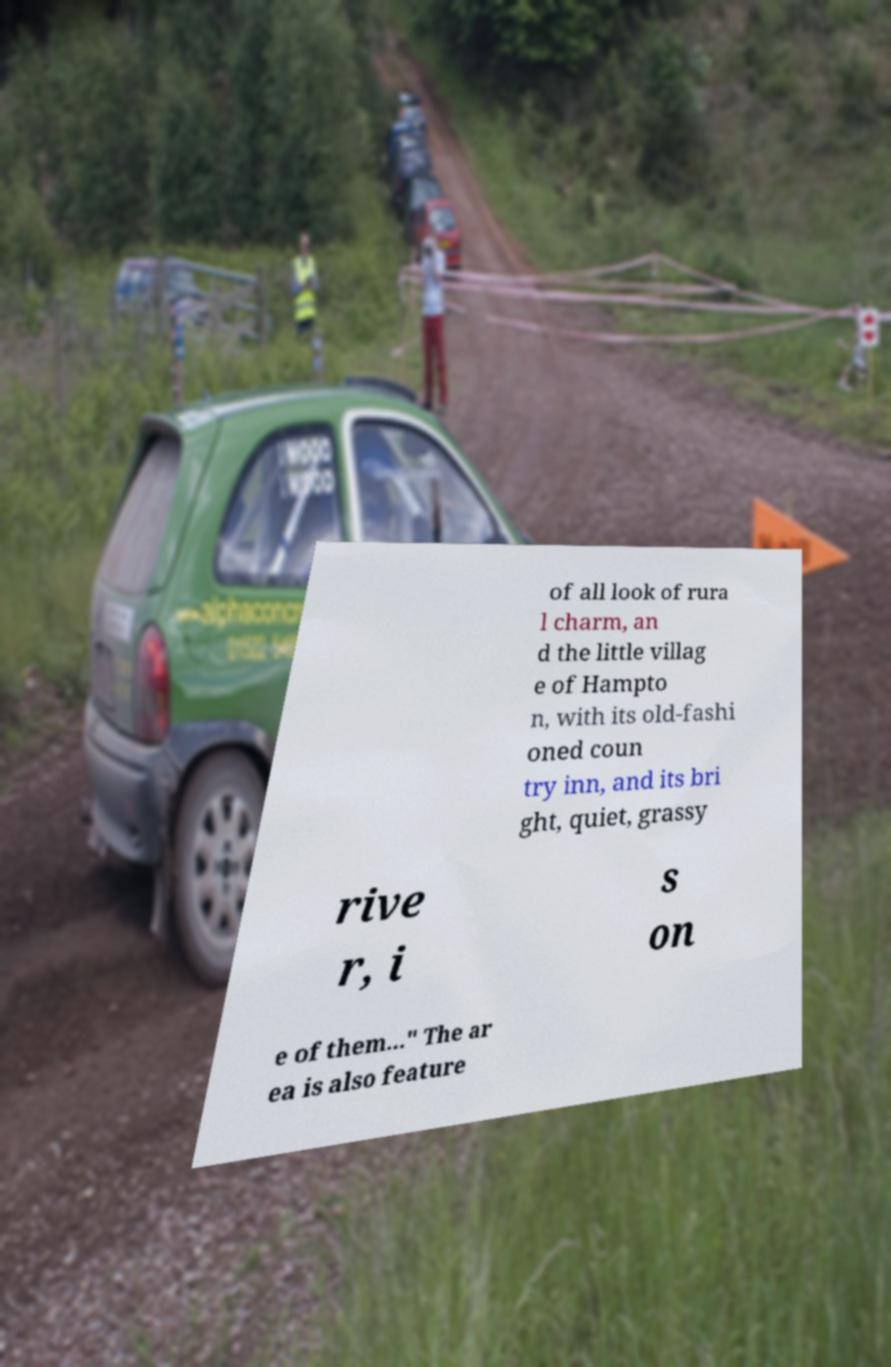Can you read and provide the text displayed in the image?This photo seems to have some interesting text. Can you extract and type it out for me? of all look of rura l charm, an d the little villag e of Hampto n, with its old-fashi oned coun try inn, and its bri ght, quiet, grassy rive r, i s on e of them..." The ar ea is also feature 